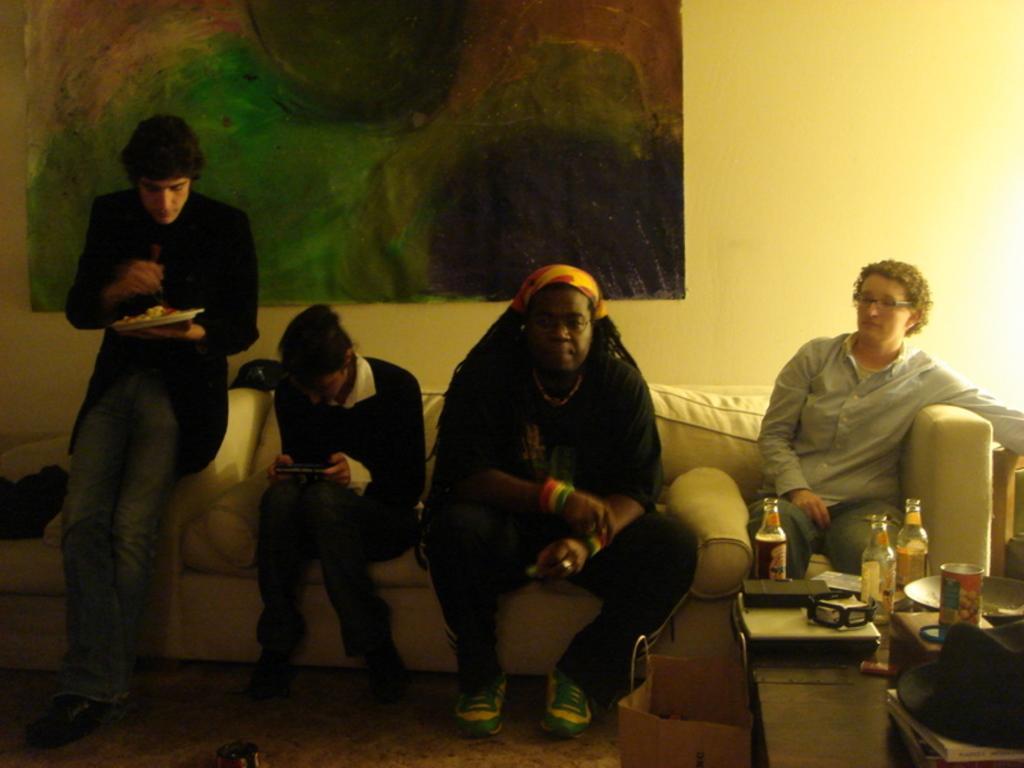Could you give a brief overview of what you see in this image? In this image we can see some people sitting on the sofa. We can see a man holding a cellphone. On the left side we can see a man holding a plate. On the right side we can see a table containing some bottles, glasses, tin and a bag. On the backside we can see a painting and a wall. 